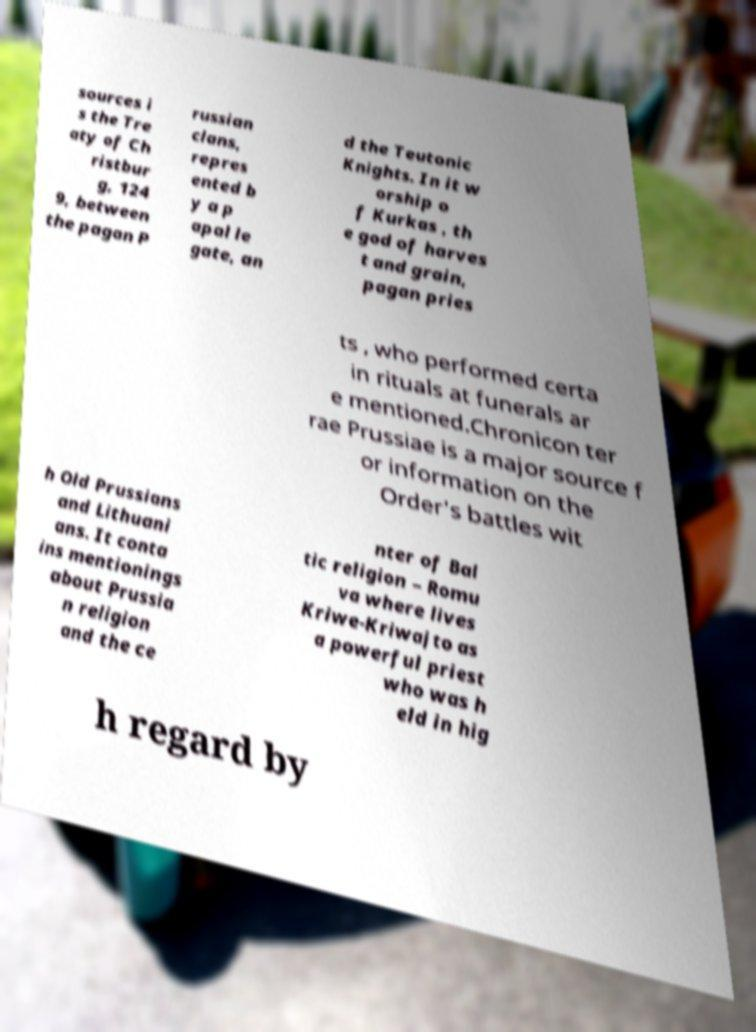I need the written content from this picture converted into text. Can you do that? sources i s the Tre aty of Ch ristbur g, 124 9, between the pagan P russian clans, repres ented b y a p apal le gate, an d the Teutonic Knights. In it w orship o f Kurkas , th e god of harves t and grain, pagan pries ts , who performed certa in rituals at funerals ar e mentioned.Chronicon ter rae Prussiae is a major source f or information on the Order's battles wit h Old Prussians and Lithuani ans. It conta ins mentionings about Prussia n religion and the ce nter of Bal tic religion – Romu va where lives Kriwe-Kriwajto as a powerful priest who was h eld in hig h regard by 